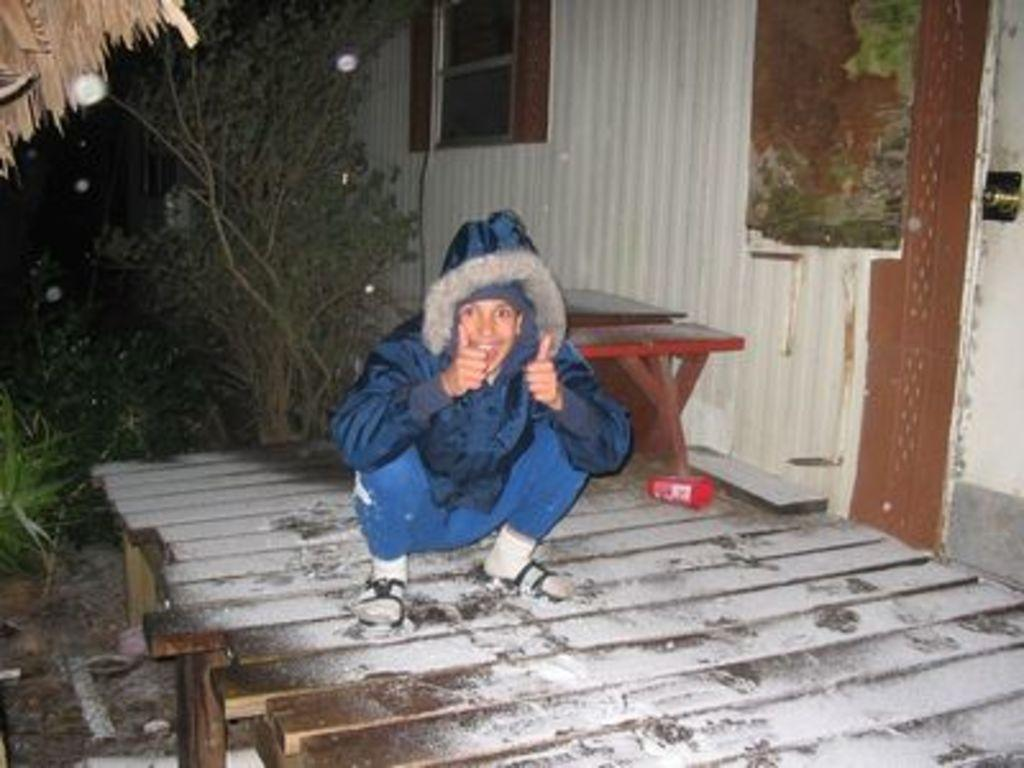What is the person in the image standing on? The person is standing on a wooden platform in the image. What object can be seen in the image that is typically used for placing items? There is a table in the image. What type of structure is visible in the image? There is a building in the image. What type of vegetation can be seen in the image? There are plants and trees in the image. What can be seen in the image that provides illumination? There are lights in the image. What type of bottle is being used to measure the mass of the person in the image? There is no bottle present in the image, and the person's mass is not being measured. What scale is being used to determine the size of the building in the image? There is no scale present in the image, and the size of the building is not being determined. 